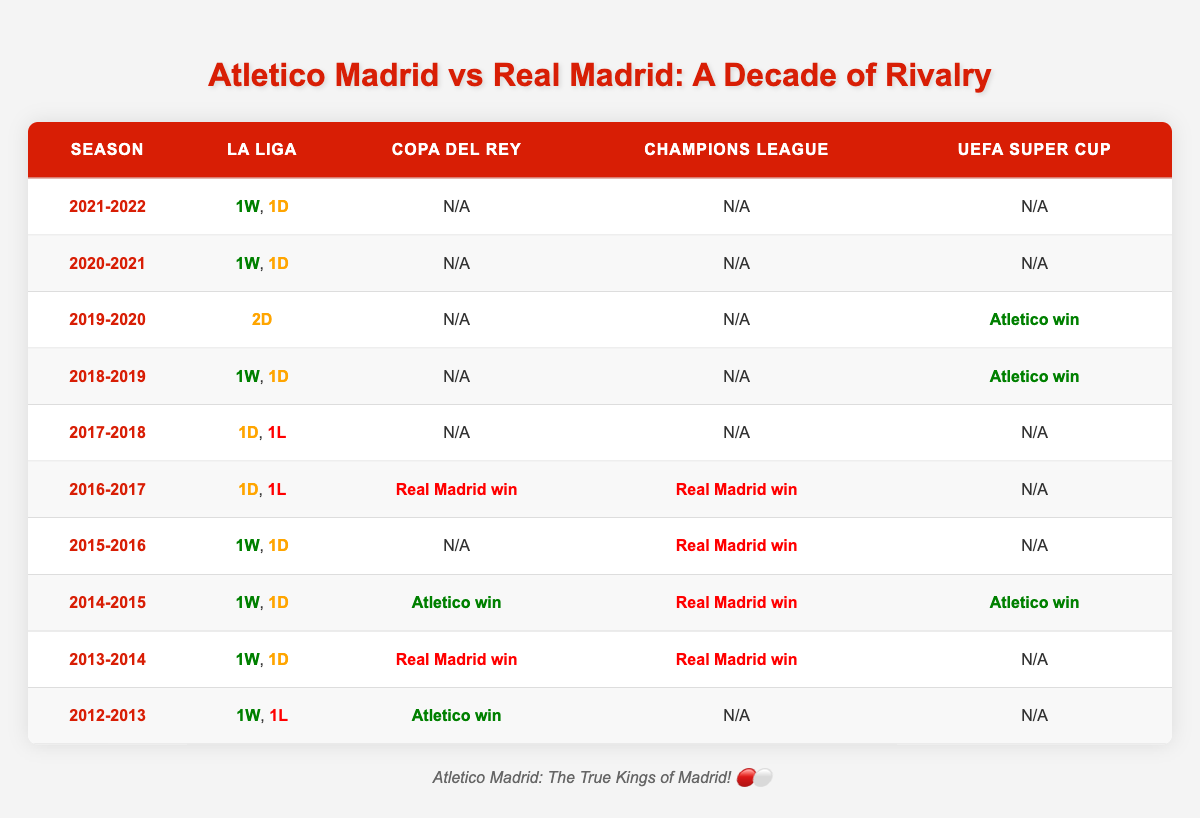What was Atletico Madrid's performance in La Liga during the 2021-2022 season? Atletico Madrid had a record of 1 win and 1 draw in La Liga during the 2021-2022 season.
Answer: 1W, 1D How many competitions did Atletico Madrid win against Real Madrid in the decade? Atletico Madrid won in the UEFA Super Cup in the 2019-2020 season, in Copa del Rey in the 2014-2015 season, and also in the UEFA Super Cup in the same season. Therefore, they secured 3 wins against Real Madrid across different competitions in the decade.
Answer: 3 Did Real Madrid win any matches against Atletico Madrid in the Champions League during this period? Yes, Real Madrid won in the Champions League during the 2015-2016 and 2016-2017 seasons.
Answer: Yes Which season had the most draws in head-to-head contests? The 2019-2020 season had the most draws with 2 draws recorded in La Liga.
Answer: 2019-2020 In how many seasons did Atletico Madrid win in the UEFA Super Cup against Real Madrid? Atletico Madrid won the UEFA Super Cup twice against Real Madrid: once in 2014-2015 and once in 2019-2020. Thus, there are 2 seasons where Atletico Madrid emerged victorious.
Answer: 2 How does Atletico Madrid's total wins in La Liga compare to Real Madrid's wins in the same competition? Atletico Madrid had 5 wins (1W each in 2014-2015, 2015-2016, 2018-2019, 2020-2021, 2021-2022) while Real Madrid had only 1 win (in 2017-2018). Therefore, Atletico Madrid has more wins than Real Madrid in La Liga.
Answer: Atletico Madrid has more wins What was the result of Atletico Madrid vs Real Madrid in the Copa del Rey during the 2014-2015 season? Atletico Madrid won the match in the Copa del Rey during the 2014-2015 season against Real Madrid.
Answer: Atletico win In which season did Atletico Madrid fail to secure a single win against Real Madrid? In the 2016-2017 season, Atletico Madrid had 1 draw and 1 loss against Real Madrid, failing to secure a win.
Answer: 2016-2017 What was the overall trend in head-to-head contests in La Liga between the two teams over the decade? The overall trend shows that Atletico Madrid had more wins (5W) compared to draws and losses combined in La Liga during the decade, indicating their competitive edge in this competition.
Answer: Competitive edge to Atletico Madrid 